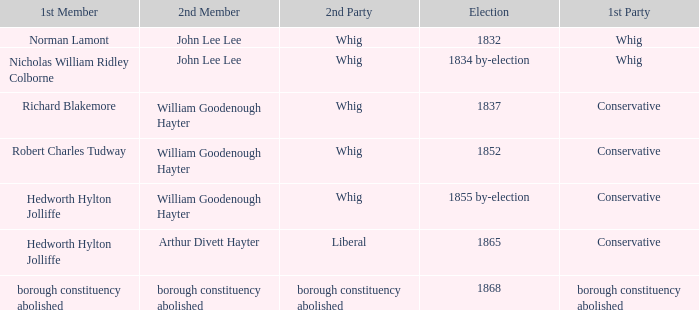What election has a 1st member of richard blakemore and a 2nd member of william goodenough hayter? 1837.0. 